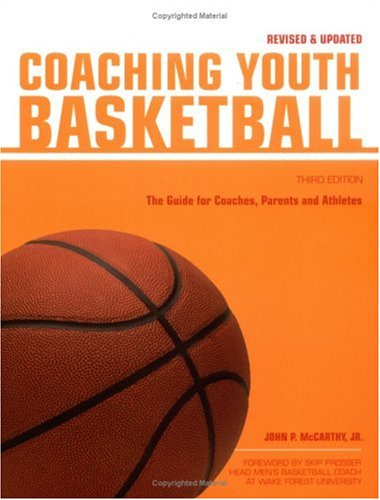Is this a games related book? Yes, it is a game-related book, focusing on the sport of basketball and provides insights into coaching strategies and tips for youth players. 